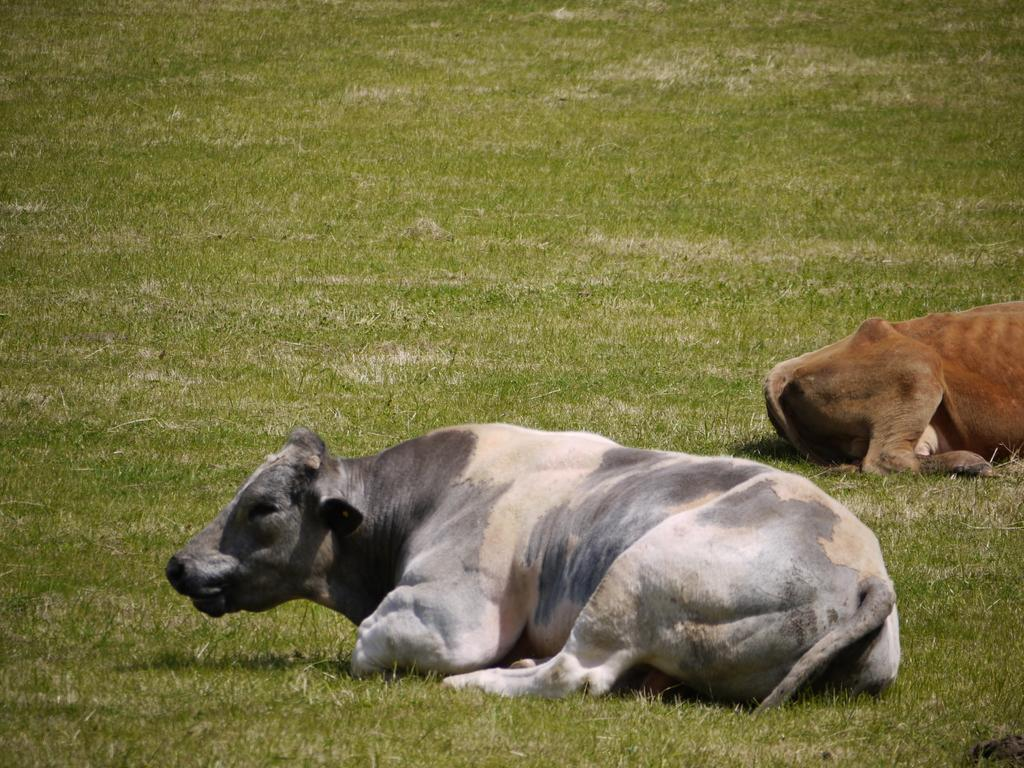What type of animal is present in the image? There is a cow in the image. Can you describe the other animal in the image? There is another animal laying on the ground in the image. What color is the bean that the cow is holding in the image? There is no bean present in the image, and the cow is not holding anything. 